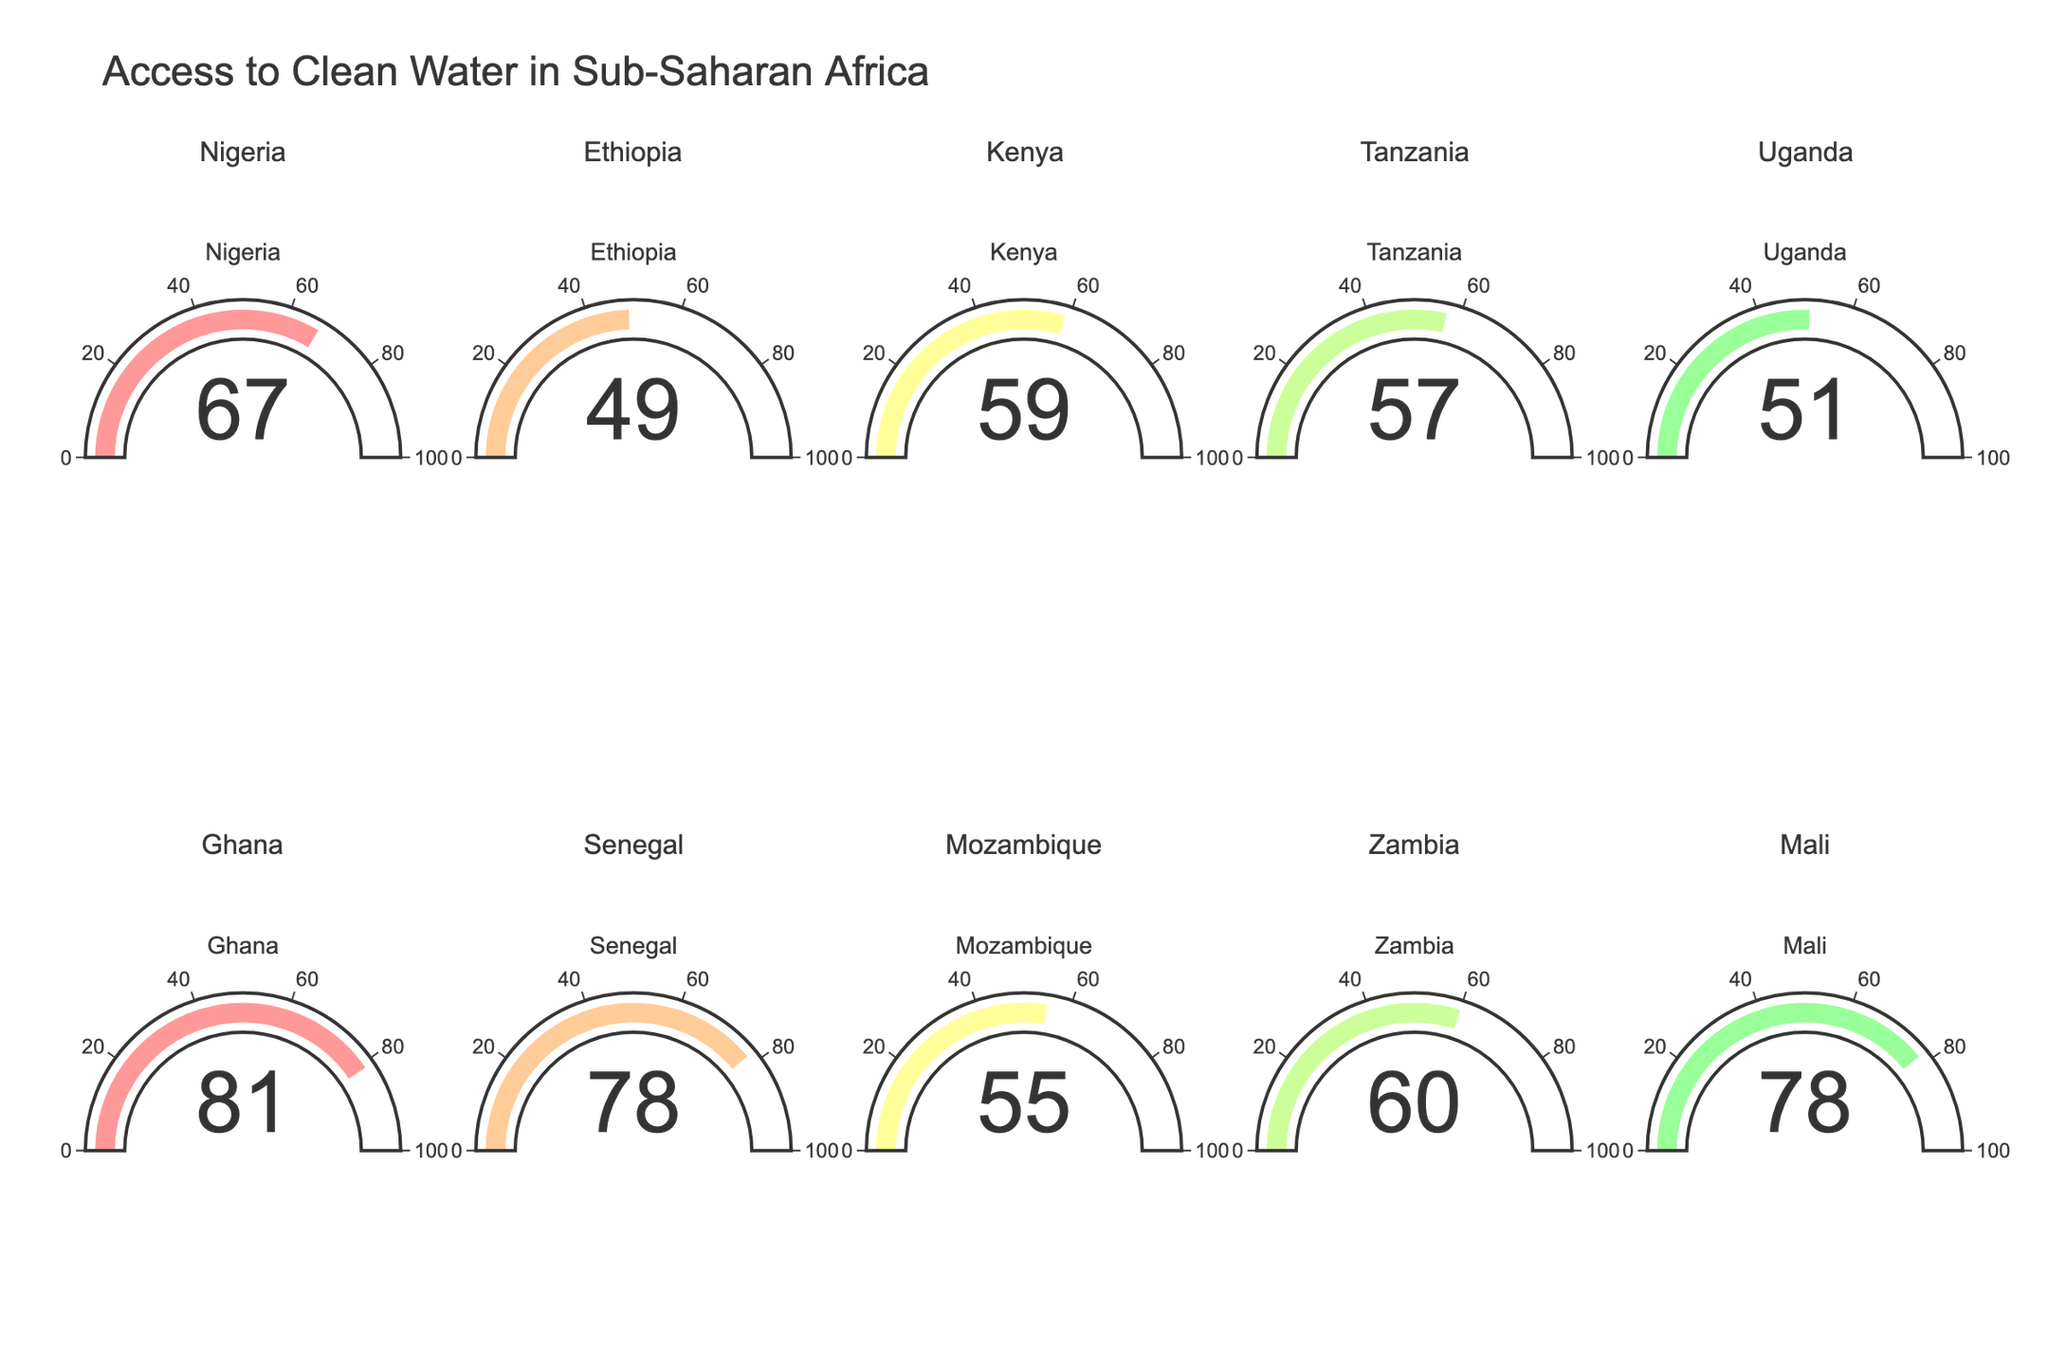What's the title of the figure? The title of the figure is usually displayed prominently at the top. In this case, it is "Access to Clean Water in Sub-Saharan Africa."
Answer: Access to Clean Water in Sub-Saharan Africa How many countries are represented in the figure? The figure is divided into subplots, with each subplot representing a different country. You can count the subplots to determine the number of countries. There are 10 subplots.
Answer: 10 Which country has the highest percentage of the population with access to clean water? By looking at the numbers on each gauge, you can compare the values. The highest percentage is 81%, which corresponds to Ghana.
Answer: Ghana What is the median percentage of access to clean water across the listed countries? First, list out the percentages: [67, 49, 59, 57, 51, 81, 78, 55, 60, 78]. Sort them: [49, 51, 55, 57, 59, 60, 67, 78, 78, 81]. The median value in this sorted list of 10 elements is the average of the 5th and 6th elements: (59 + 60) / 2 = 59.5
Answer: 59.5 Which countries have access to clean water percentages above 75%? Examine the gauges to identify percentages above 75%. These countries are Ghana (81%), Senegal (78%), and Mali (78%).
Answer: Ghana, Senegal, Mali What is the difference in the percentage of access to clean water between Nigeria and Ethiopia? Find the values for Nigeria (67%) and Ethiopia (49%) and compute the difference: 67 - 49 = 18
Answer: 18 How many countries have an access percentage below 60%? Check each gauge and count the countries below 60%. These countries are Ethiopia (49%), Uganda (51%), Tanzania (57%), and Mozambique (55%), making a total of 4 countries.
Answer: 4 What is the average percentage of access to clean water for all the countries listed? Sum up all the percentages: 67 + 49 + 59 + 57 + 51 + 81 + 78 + 55 + 60 + 78 = 635. Divide by the number of countries (10): 635 / 10 = 63.5
Answer: 63.5 Which country has the lowest percentage of the population with access to clean water? By looking at the gauges, the lowest value is 49%, which corresponds to Ethiopia.
Answer: Ethiopia 